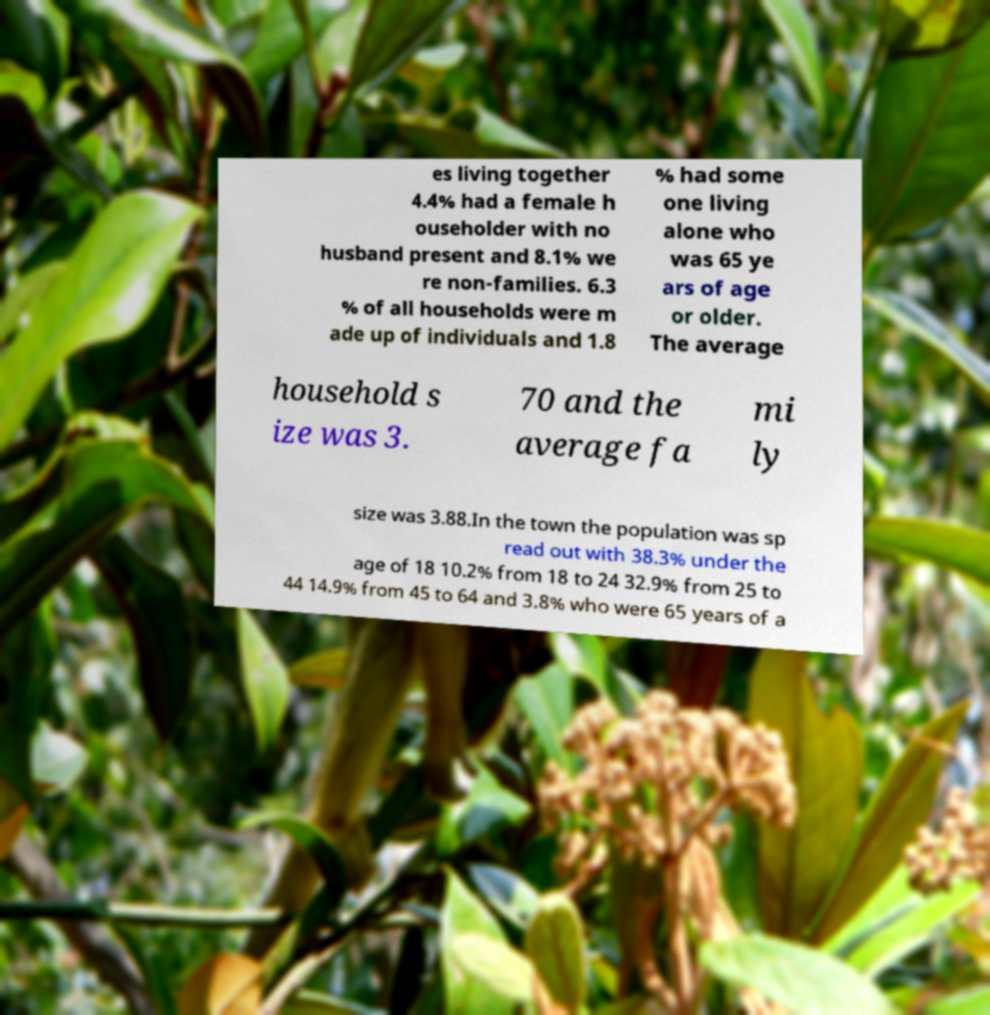I need the written content from this picture converted into text. Can you do that? es living together 4.4% had a female h ouseholder with no husband present and 8.1% we re non-families. 6.3 % of all households were m ade up of individuals and 1.8 % had some one living alone who was 65 ye ars of age or older. The average household s ize was 3. 70 and the average fa mi ly size was 3.88.In the town the population was sp read out with 38.3% under the age of 18 10.2% from 18 to 24 32.9% from 25 to 44 14.9% from 45 to 64 and 3.8% who were 65 years of a 